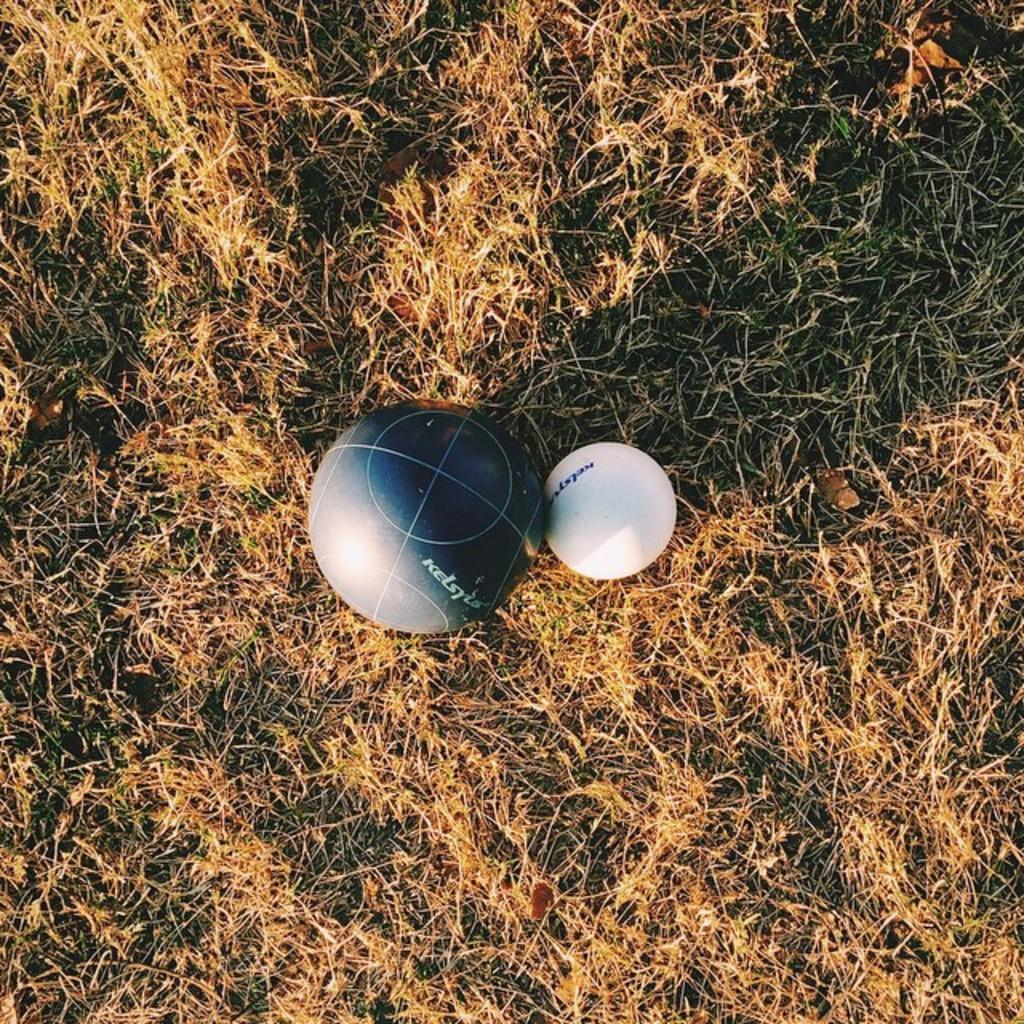Can you describe this image briefly? At the bottom, we see the dry grass. In the middle, we see the balls in white and grey color. 